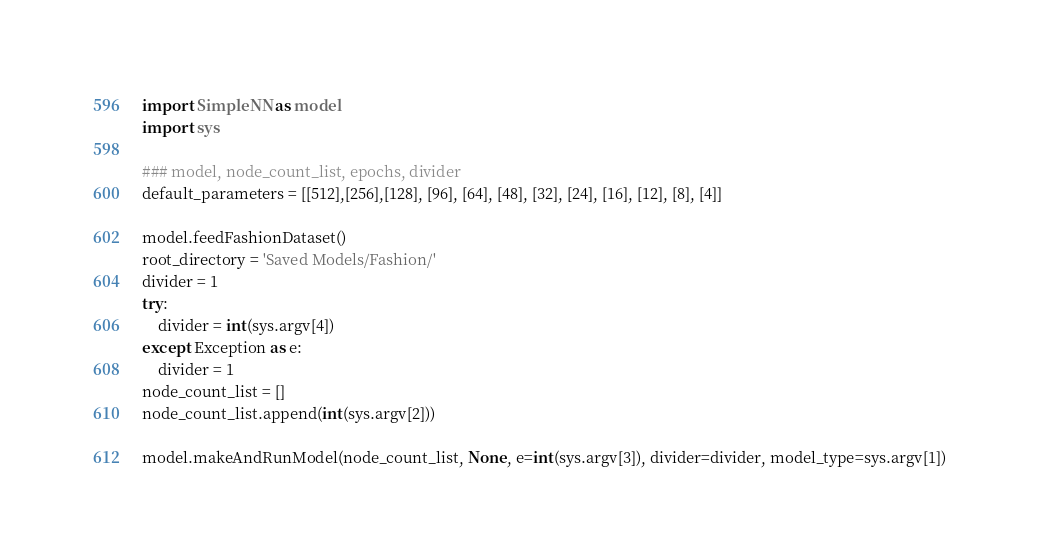<code> <loc_0><loc_0><loc_500><loc_500><_Python_>
import SimpleNN as model
import sys

### model, node_count_list, epochs, divider
default_parameters = [[512],[256],[128], [96], [64], [48], [32], [24], [16], [12], [8], [4]]

model.feedFashionDataset()
root_directory = 'Saved Models/Fashion/'
divider = 1
try:
	divider = int(sys.argv[4])
except Exception as e:
	divider = 1
node_count_list = []
node_count_list.append(int(sys.argv[2]))

model.makeAndRunModel(node_count_list, None, e=int(sys.argv[3]), divider=divider, model_type=sys.argv[1])
</code> 